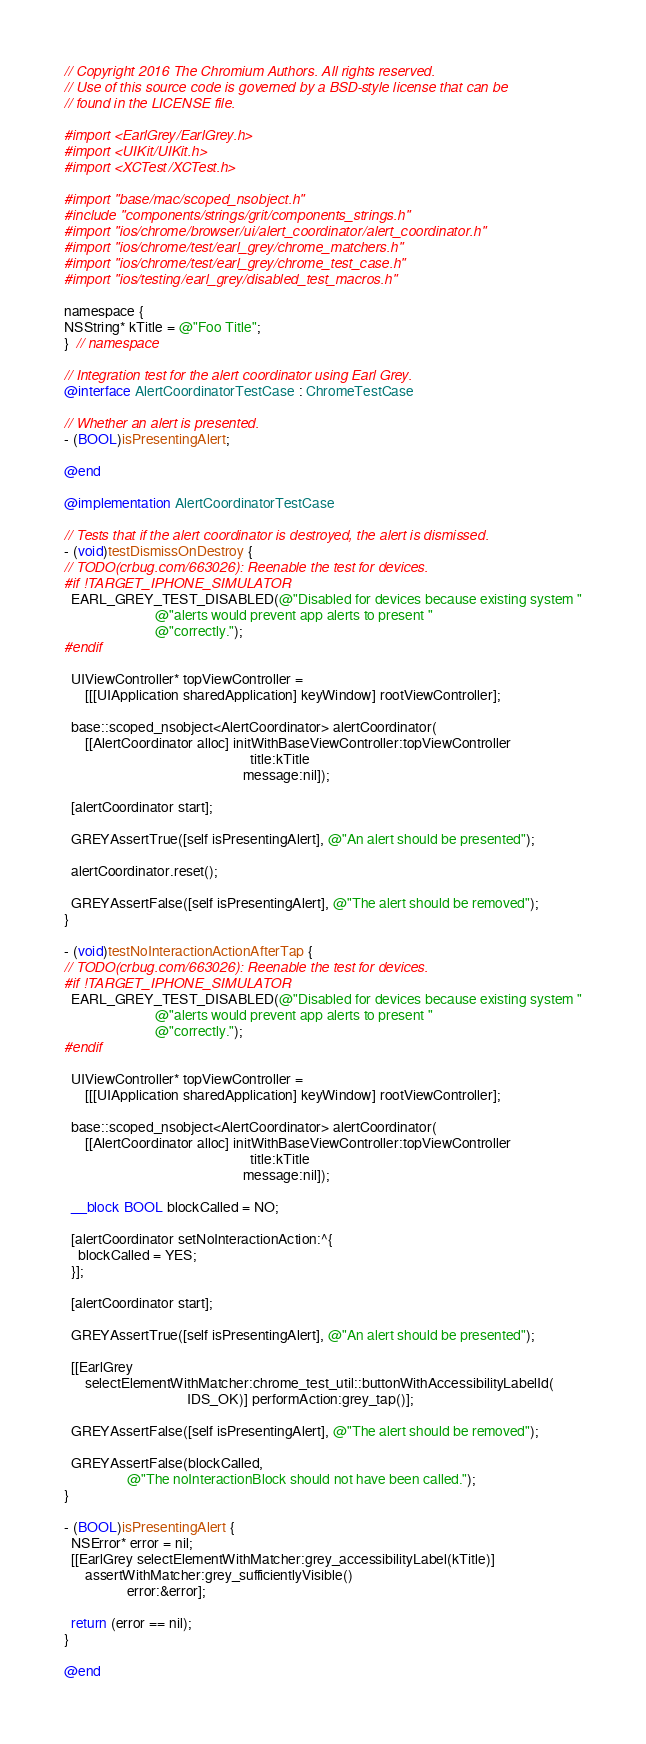<code> <loc_0><loc_0><loc_500><loc_500><_ObjectiveC_>// Copyright 2016 The Chromium Authors. All rights reserved.
// Use of this source code is governed by a BSD-style license that can be
// found in the LICENSE file.

#import <EarlGrey/EarlGrey.h>
#import <UIKit/UIKit.h>
#import <XCTest/XCTest.h>

#import "base/mac/scoped_nsobject.h"
#include "components/strings/grit/components_strings.h"
#import "ios/chrome/browser/ui/alert_coordinator/alert_coordinator.h"
#import "ios/chrome/test/earl_grey/chrome_matchers.h"
#import "ios/chrome/test/earl_grey/chrome_test_case.h"
#import "ios/testing/earl_grey/disabled_test_macros.h"

namespace {
NSString* kTitle = @"Foo Title";
}  // namespace

// Integration test for the alert coordinator using Earl Grey.
@interface AlertCoordinatorTestCase : ChromeTestCase

// Whether an alert is presented.
- (BOOL)isPresentingAlert;

@end

@implementation AlertCoordinatorTestCase

// Tests that if the alert coordinator is destroyed, the alert is dismissed.
- (void)testDismissOnDestroy {
// TODO(crbug.com/663026): Reenable the test for devices.
#if !TARGET_IPHONE_SIMULATOR
  EARL_GREY_TEST_DISABLED(@"Disabled for devices because existing system "
                          @"alerts would prevent app alerts to present "
                          @"correctly.");
#endif

  UIViewController* topViewController =
      [[[UIApplication sharedApplication] keyWindow] rootViewController];

  base::scoped_nsobject<AlertCoordinator> alertCoordinator(
      [[AlertCoordinator alloc] initWithBaseViewController:topViewController
                                                     title:kTitle
                                                   message:nil]);

  [alertCoordinator start];

  GREYAssertTrue([self isPresentingAlert], @"An alert should be presented");

  alertCoordinator.reset();

  GREYAssertFalse([self isPresentingAlert], @"The alert should be removed");
}

- (void)testNoInteractionActionAfterTap {
// TODO(crbug.com/663026): Reenable the test for devices.
#if !TARGET_IPHONE_SIMULATOR
  EARL_GREY_TEST_DISABLED(@"Disabled for devices because existing system "
                          @"alerts would prevent app alerts to present "
                          @"correctly.");
#endif

  UIViewController* topViewController =
      [[[UIApplication sharedApplication] keyWindow] rootViewController];

  base::scoped_nsobject<AlertCoordinator> alertCoordinator(
      [[AlertCoordinator alloc] initWithBaseViewController:topViewController
                                                     title:kTitle
                                                   message:nil]);

  __block BOOL blockCalled = NO;

  [alertCoordinator setNoInteractionAction:^{
    blockCalled = YES;
  }];

  [alertCoordinator start];

  GREYAssertTrue([self isPresentingAlert], @"An alert should be presented");

  [[EarlGrey
      selectElementWithMatcher:chrome_test_util::buttonWithAccessibilityLabelId(
                                   IDS_OK)] performAction:grey_tap()];

  GREYAssertFalse([self isPresentingAlert], @"The alert should be removed");

  GREYAssertFalse(blockCalled,
                  @"The noInteractionBlock should not have been called.");
}

- (BOOL)isPresentingAlert {
  NSError* error = nil;
  [[EarlGrey selectElementWithMatcher:grey_accessibilityLabel(kTitle)]
      assertWithMatcher:grey_sufficientlyVisible()
                  error:&error];

  return (error == nil);
}

@end
</code> 